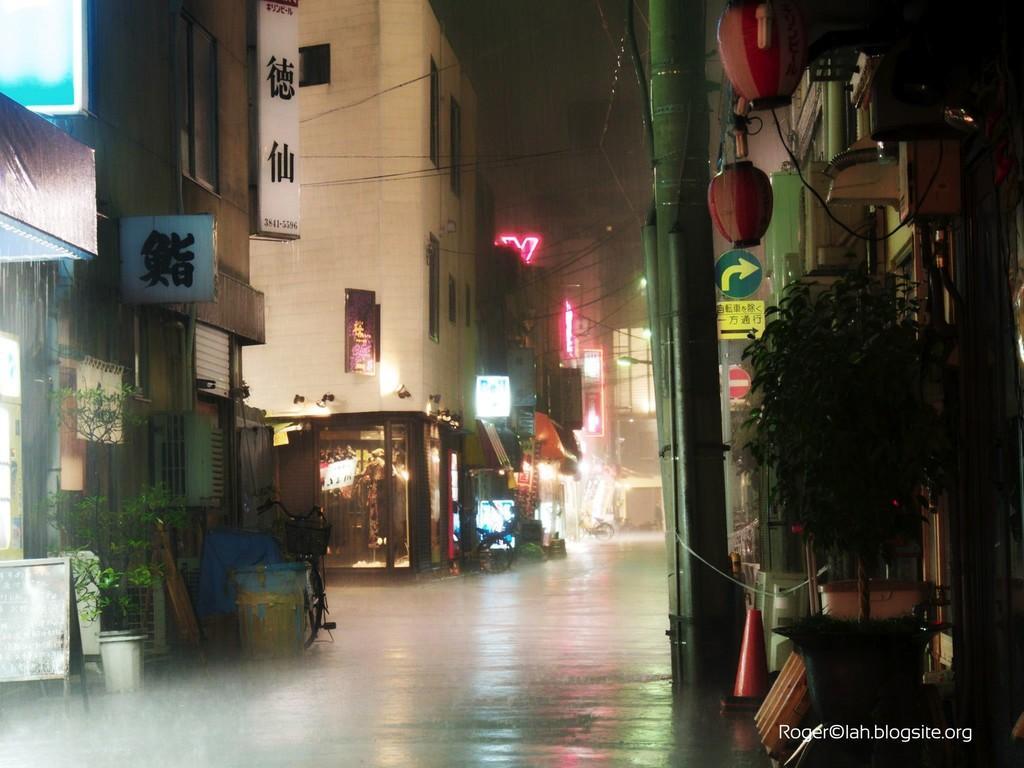Could you give a brief overview of what you see in this image? This picture is clicked outside the city. On the right side, we see a flower pot, pole, lanterns and buildings. On the left side, we see a flower pot, board, bicycle and building. In the background, we see buildings and hoarding boards with some text written on it. At the top, we see the sky and it is a rainy day. 